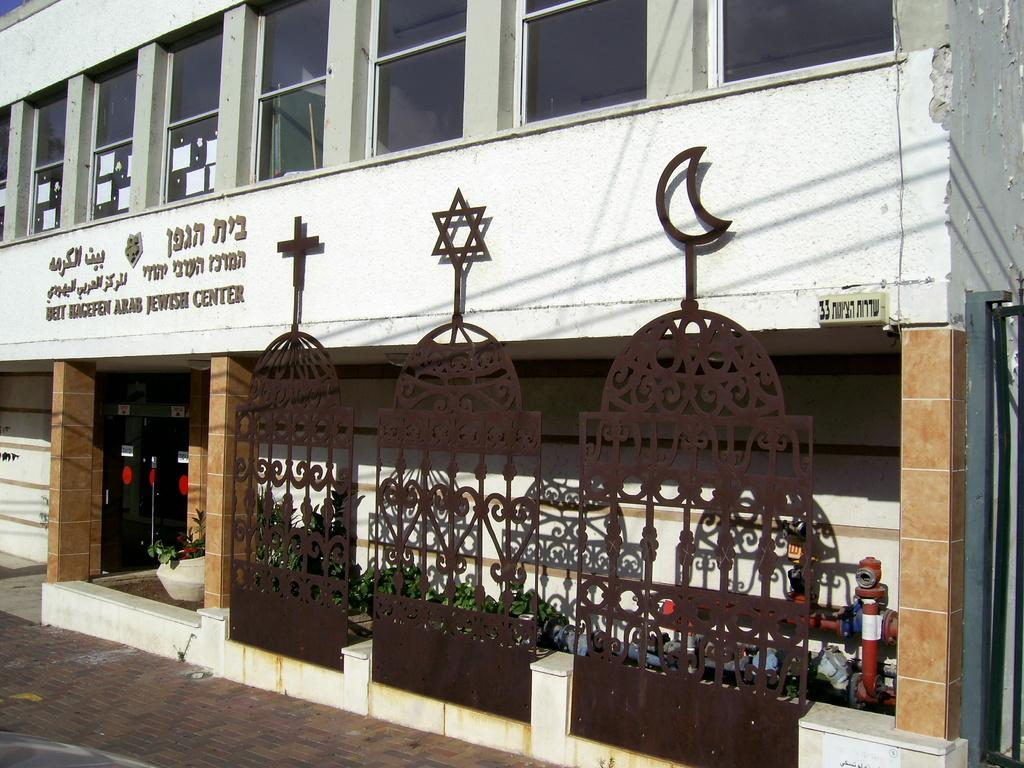What type of structure is in the picture? There is a building in the picture. What can be seen at the bottom of the picture? Flower pots, a pipe, and other objects are present at the bottom of the picture. What feature of the building is visible at the top? There are windows at the top of the building in the picture. What type of cap is being worn by the soldier in the picture? There is no soldier or cap present in the picture; it features a building with windows and flower pots at the bottom. What type of plate is being used to serve food in the picture? There is no plate or food present in the picture; it only shows a building with windows and flower pots at the bottom. 